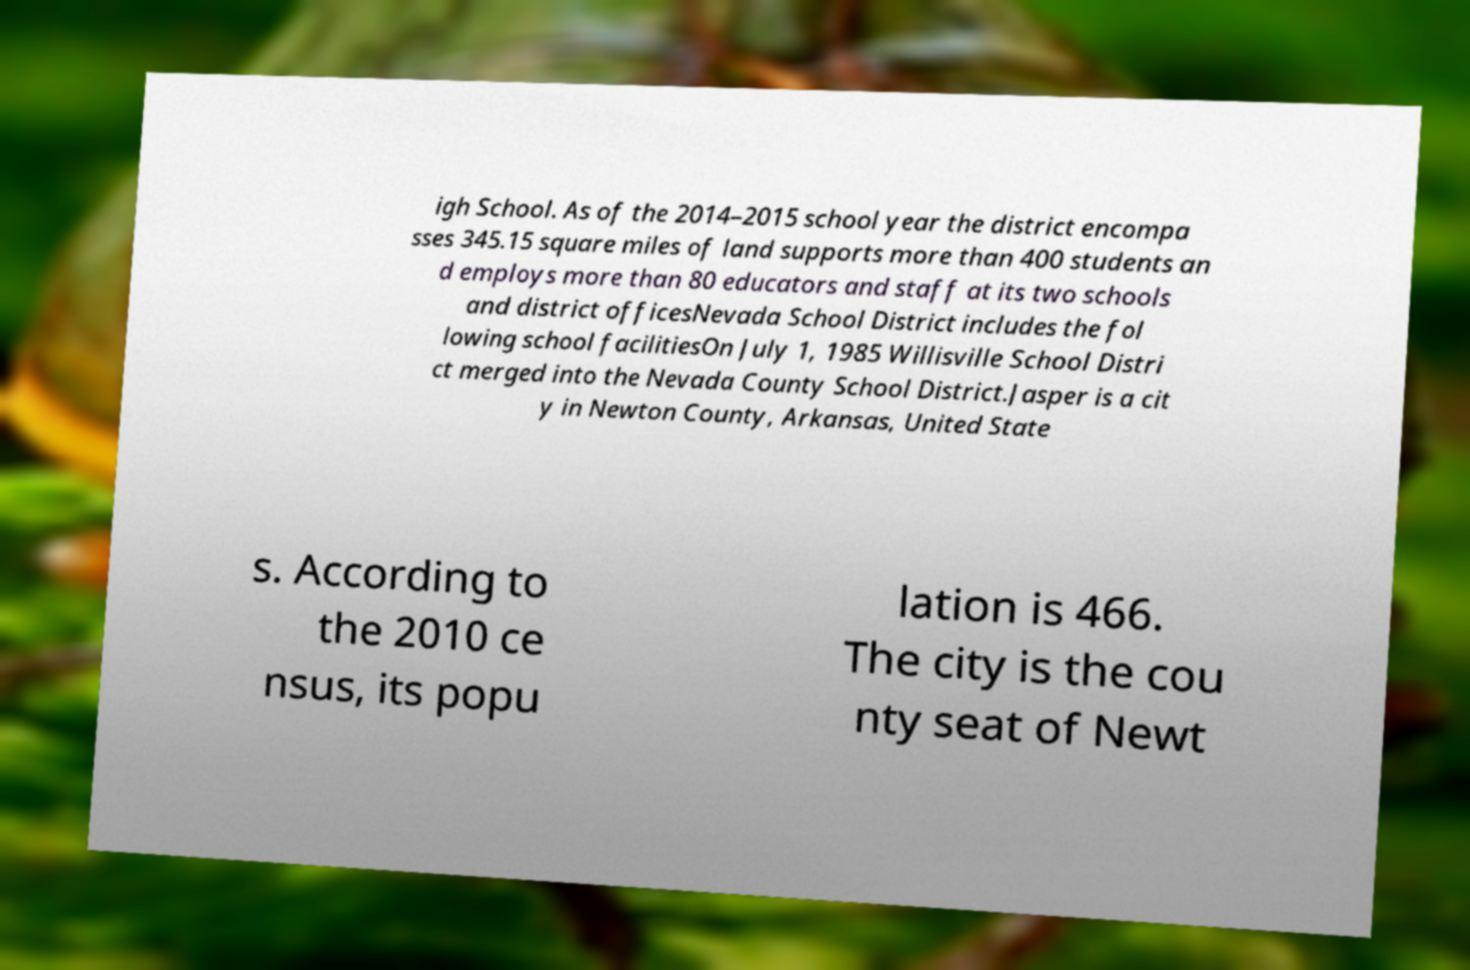Could you extract and type out the text from this image? igh School. As of the 2014–2015 school year the district encompa sses 345.15 square miles of land supports more than 400 students an d employs more than 80 educators and staff at its two schools and district officesNevada School District includes the fol lowing school facilitiesOn July 1, 1985 Willisville School Distri ct merged into the Nevada County School District.Jasper is a cit y in Newton County, Arkansas, United State s. According to the 2010 ce nsus, its popu lation is 466. The city is the cou nty seat of Newt 